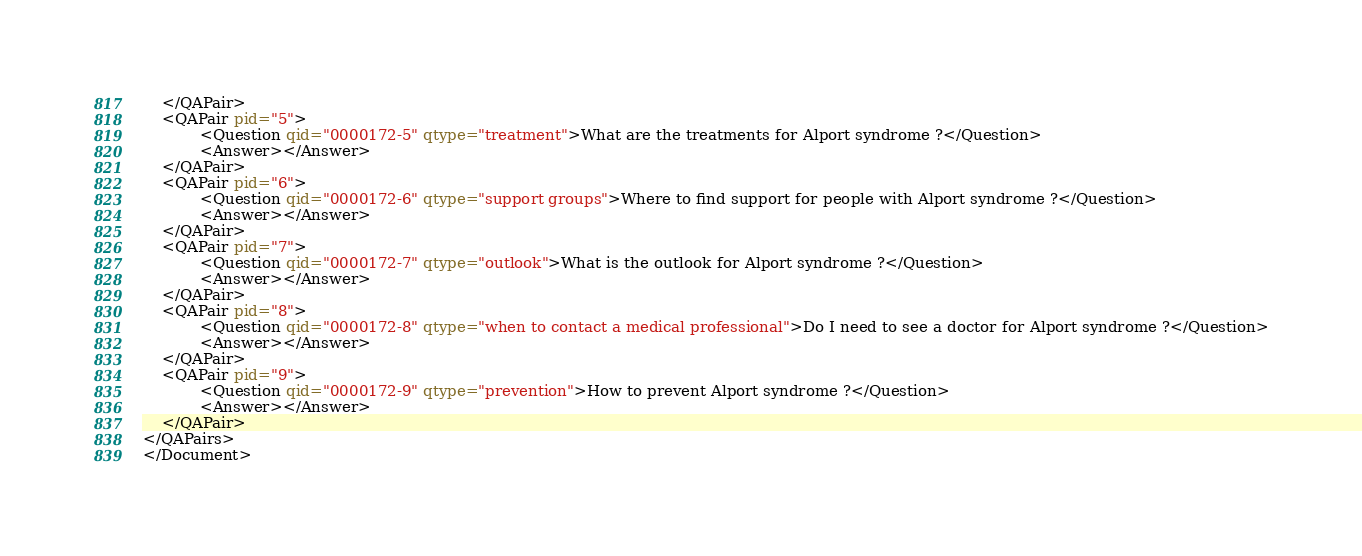<code> <loc_0><loc_0><loc_500><loc_500><_XML_>	</QAPair>
	<QAPair pid="5">
			<Question qid="0000172-5" qtype="treatment">What are the treatments for Alport syndrome ?</Question>
			<Answer></Answer>
	</QAPair>
	<QAPair pid="6">
			<Question qid="0000172-6" qtype="support groups">Where to find support for people with Alport syndrome ?</Question>
			<Answer></Answer>
	</QAPair>
	<QAPair pid="7">
			<Question qid="0000172-7" qtype="outlook">What is the outlook for Alport syndrome ?</Question>
			<Answer></Answer>
	</QAPair>
	<QAPair pid="8">
			<Question qid="0000172-8" qtype="when to contact a medical professional">Do I need to see a doctor for Alport syndrome ?</Question>
			<Answer></Answer>
	</QAPair>
	<QAPair pid="9">
			<Question qid="0000172-9" qtype="prevention">How to prevent Alport syndrome ?</Question>
			<Answer></Answer>
	</QAPair>
</QAPairs>
</Document>
</code> 